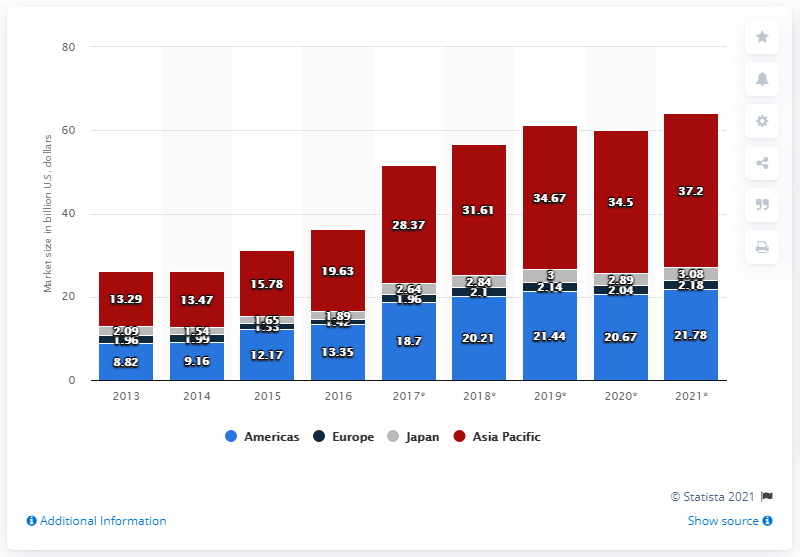Mention a couple of crucial points in this snapshot. The estimated value of the flash memory market in the United States in 2017 was 18.7. 